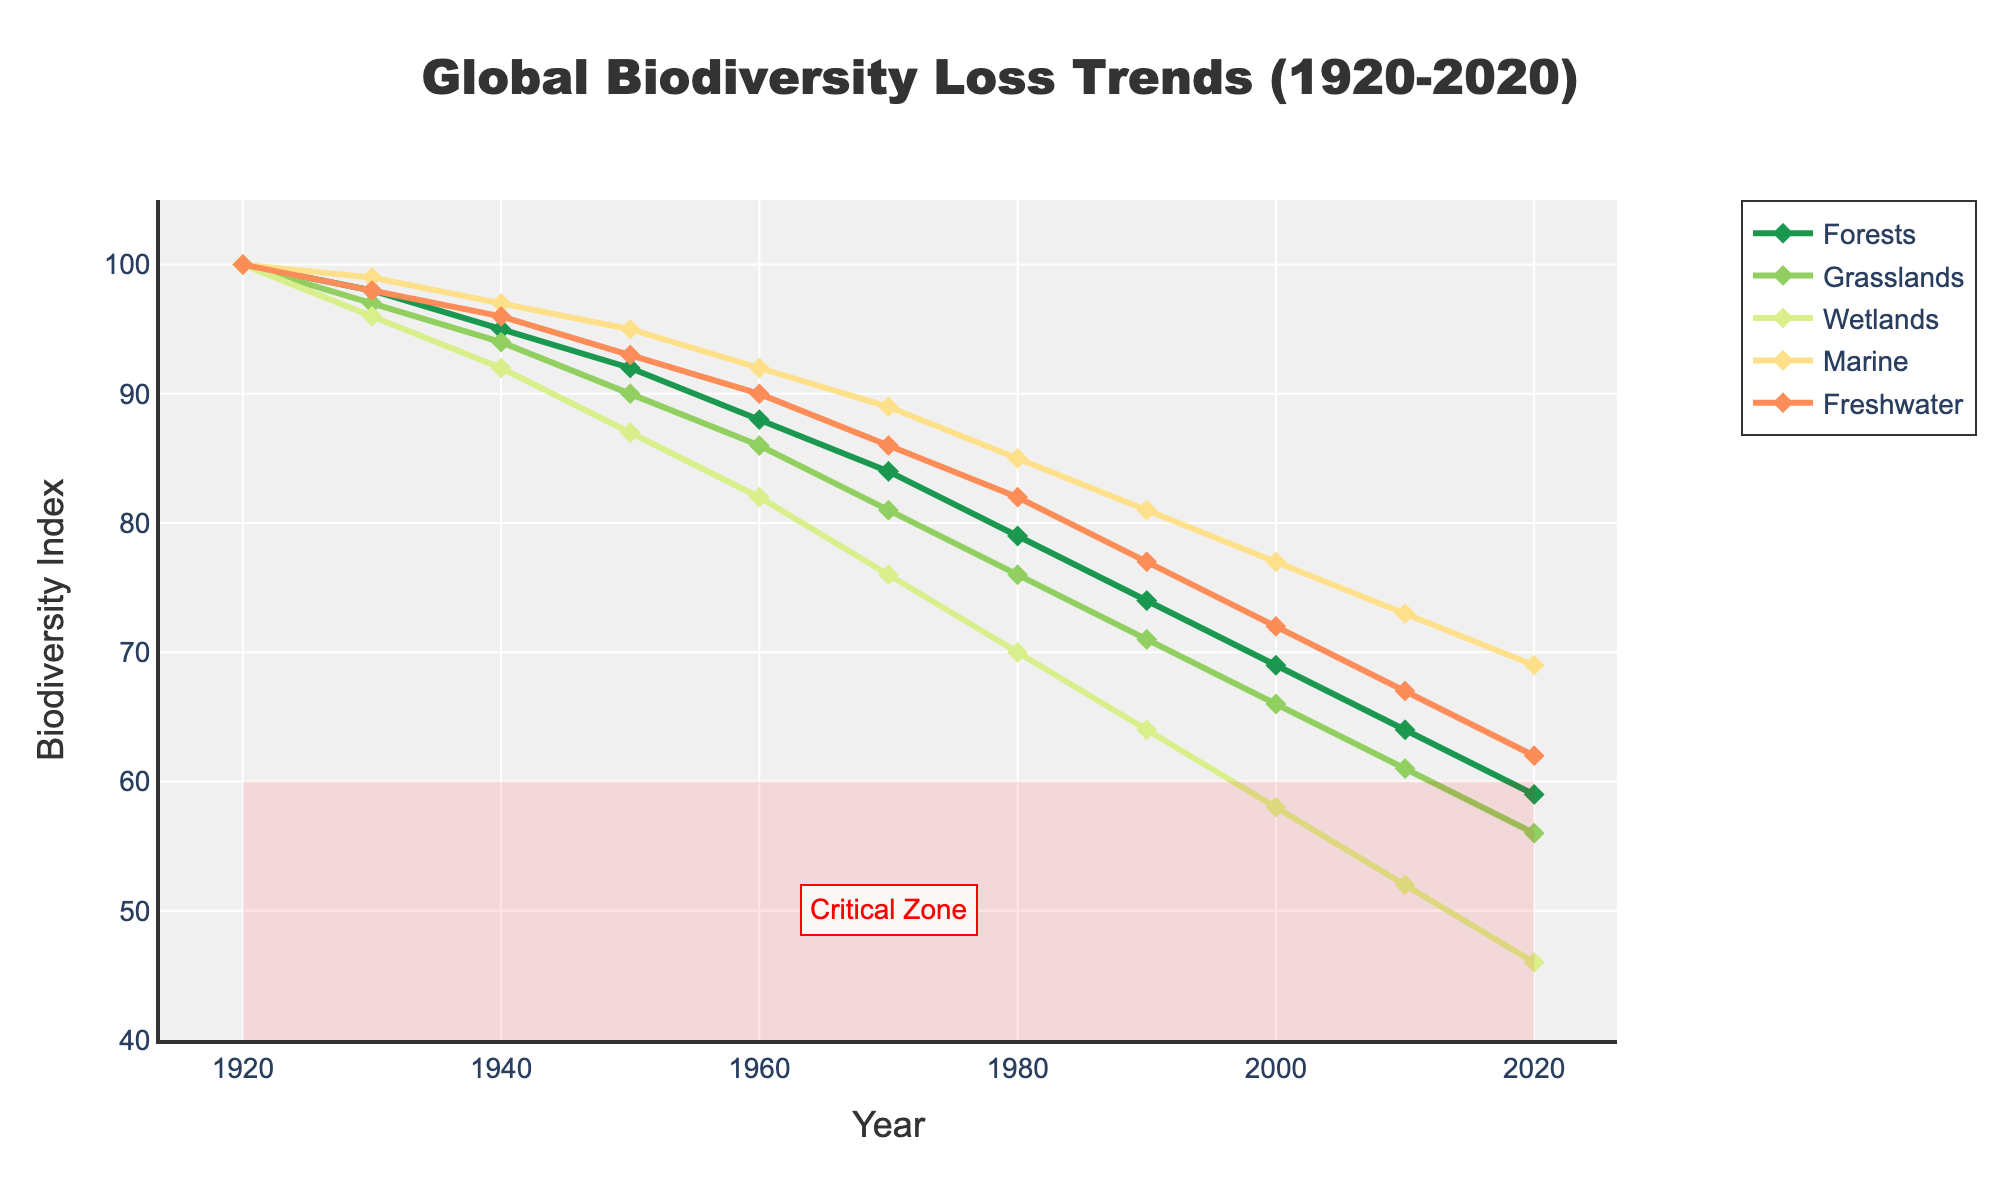What ecosystem type experienced the greatest biodiversity loss between 1920 and 2020? Look at the starting and ending values for each ecosystem type on the y-axis. The Forests ecosystem starts at 100 in 1920 and declines to 59 in 2020, a loss of 41 units. For other ecosystems: Grasslands (41 units), Wetlands (54 units), Marine (31 units), and Freshwater (38 units). Wetlands have the greatest loss.
Answer: Wetlands How does the biodiversity loss in Freshwater ecosystems in 1950 compare to that in 2020? Compare the y-axis values for the Freshwater ecosystem in 1950 (93) and 2020 (62). Subtract 62 from 93 to get the loss: 31. So, from 1950 to 2020, Freshwater ecosystems lost 31 units in biodiversity.
Answer: Freshwater ecosystems lost 31 units Which ecosystem showed the smallest percentage of biodiversity loss from 1920 to 2020? Calculate the percentage loss for each ecosystem type. Forests: (100-59)/100 = 41%, Grasslands: (100-56)/100 = 44%, Wetlands: (100-46)/100 = 54%, Marine: (100-69)/100 = 31%, Freshwater: (100-62)/100 = 38%. Marine ecosystem has the smallest loss at 31%.
Answer: Marine What is the average biodiversity index for Marine ecosystems over the recorded years? Summing up the Marine values from 1920 to 2020: 100 + 99 + 97 + 95 + 92 + 89 + 85 + 81 + 77 + 73 + 69 = 957. Divide the sum by the number of years (11): 957 / 11 ≈ 87.
Answer: 87 By how much did the Grasslands ecosystem's biodiversity index decline from 1940 to 1990? Identify values for Grasslands at 1940 (94) and 1990 (71). Subtract 71 from 94 to find the decline: 94 - 71 = 23.
Answer: 23 Which ecosystem was closest to entering the critical zone by 1990, and how can you tell? Compare the biodiversity indices for 1990 with the start of the critical zone (60). Marine (81), Grasslands (71), Freshwater (77), Forests (74), Wetlands (64). Wetlands at 64 is closest to 60.
Answer: Wetlands In which decade did Wetlands experience the steepest decline in biodiversity index? Examine the declining rates each decade. Wetlands: 1920s (4 units), 1930s (8 units), 1940s (5 units), 1950s (6 units), 1960s (12 units), 1970s (6 units), 1980s (6 units). The 1960s saw a 12-unit decline, which is the steepest.
Answer: 1960s What's the change rate of the biodiversity index for Forests per decade, and how does it compare to Grasslands? For Forests, calculate the difference per decade: (100-59)/10 = 4.1 units/decade. For Grasslands: (100-56)/10 = 4.4 units/decade. Forests decline at 4.1 units/decade, Grasslands at 4.4 units/decade.
Answer: Forests: 4.1 units/decade, Grasslands: 4.4 units/decade Which ecosystems enter the critical zone after 2010, and how is it visually represented? Values in 2010: Grasslands (61), Wetlands (52), Marine (73), Freshwater (67), Forests (64). Those entering below 60 in 2020: Grasslands (56), Wetlands (46). They are within the shaded red area.
Answer: Grasslands, Wetlands Between which two decades did Marine ecosystems have no overlapping changes in biodiversity index with Freshwater? Examine Marine and Freshwater values: Marine only increases in the 1920s and Freshwater has no matching increase, declines in Marine from 1930 to 2020 overlap with Freshwater declines. No overlapping changes occur in the 1920s for Marine increases compared to consistent Freshwater decreases.
Answer: 1920 and 1930 